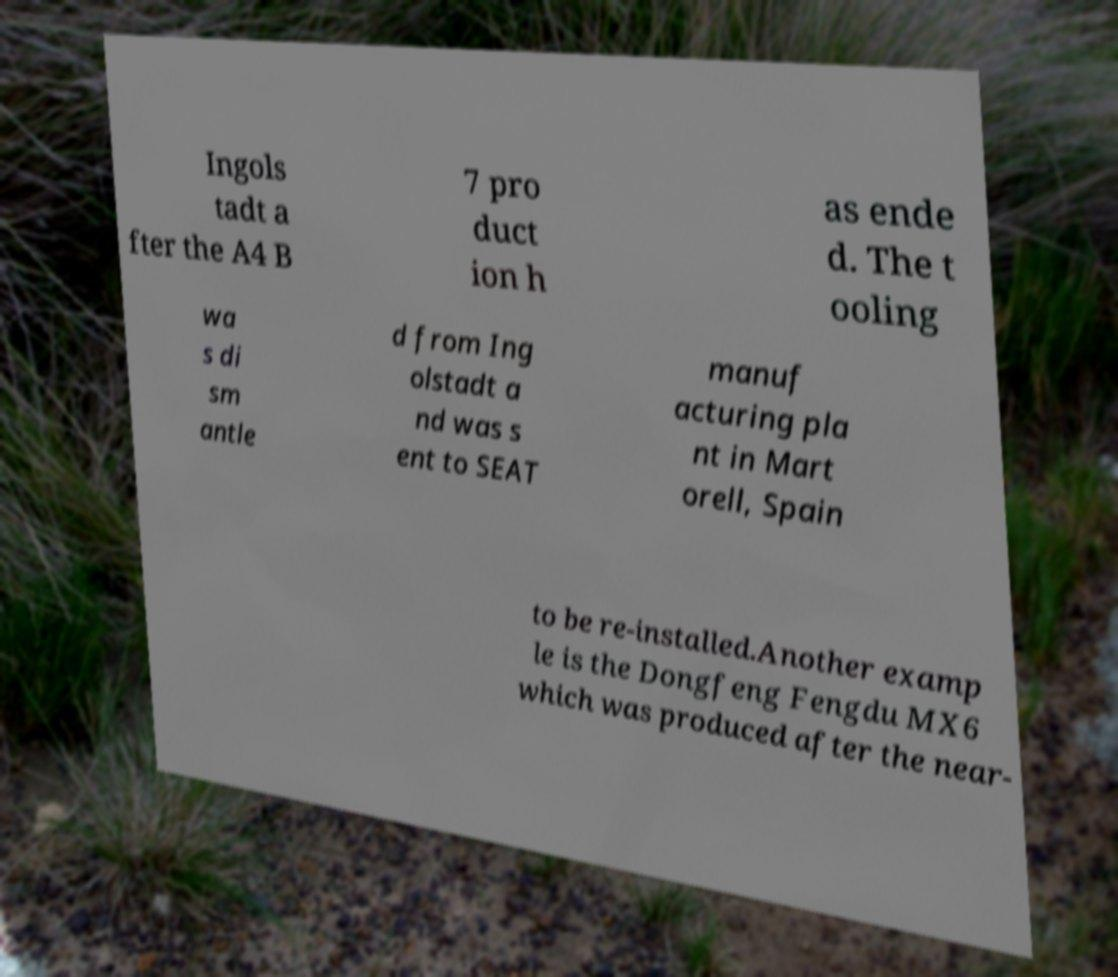For documentation purposes, I need the text within this image transcribed. Could you provide that? Ingols tadt a fter the A4 B 7 pro duct ion h as ende d. The t ooling wa s di sm antle d from Ing olstadt a nd was s ent to SEAT manuf acturing pla nt in Mart orell, Spain to be re-installed.Another examp le is the Dongfeng Fengdu MX6 which was produced after the near- 